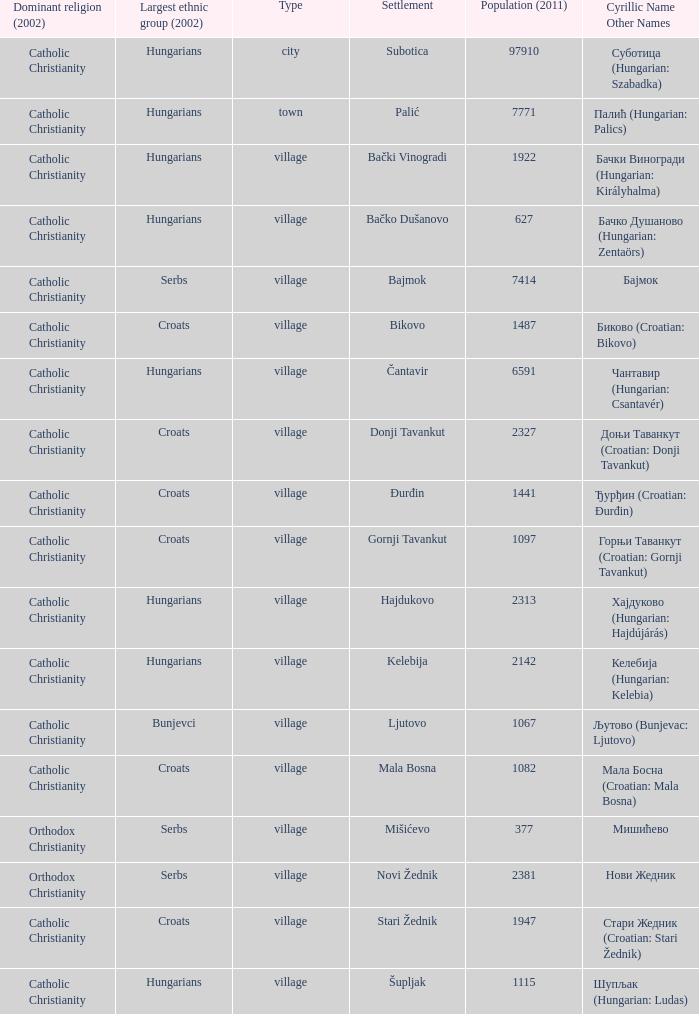What is the population in стари жедник (croatian: stari žednik)? 1947.0. 